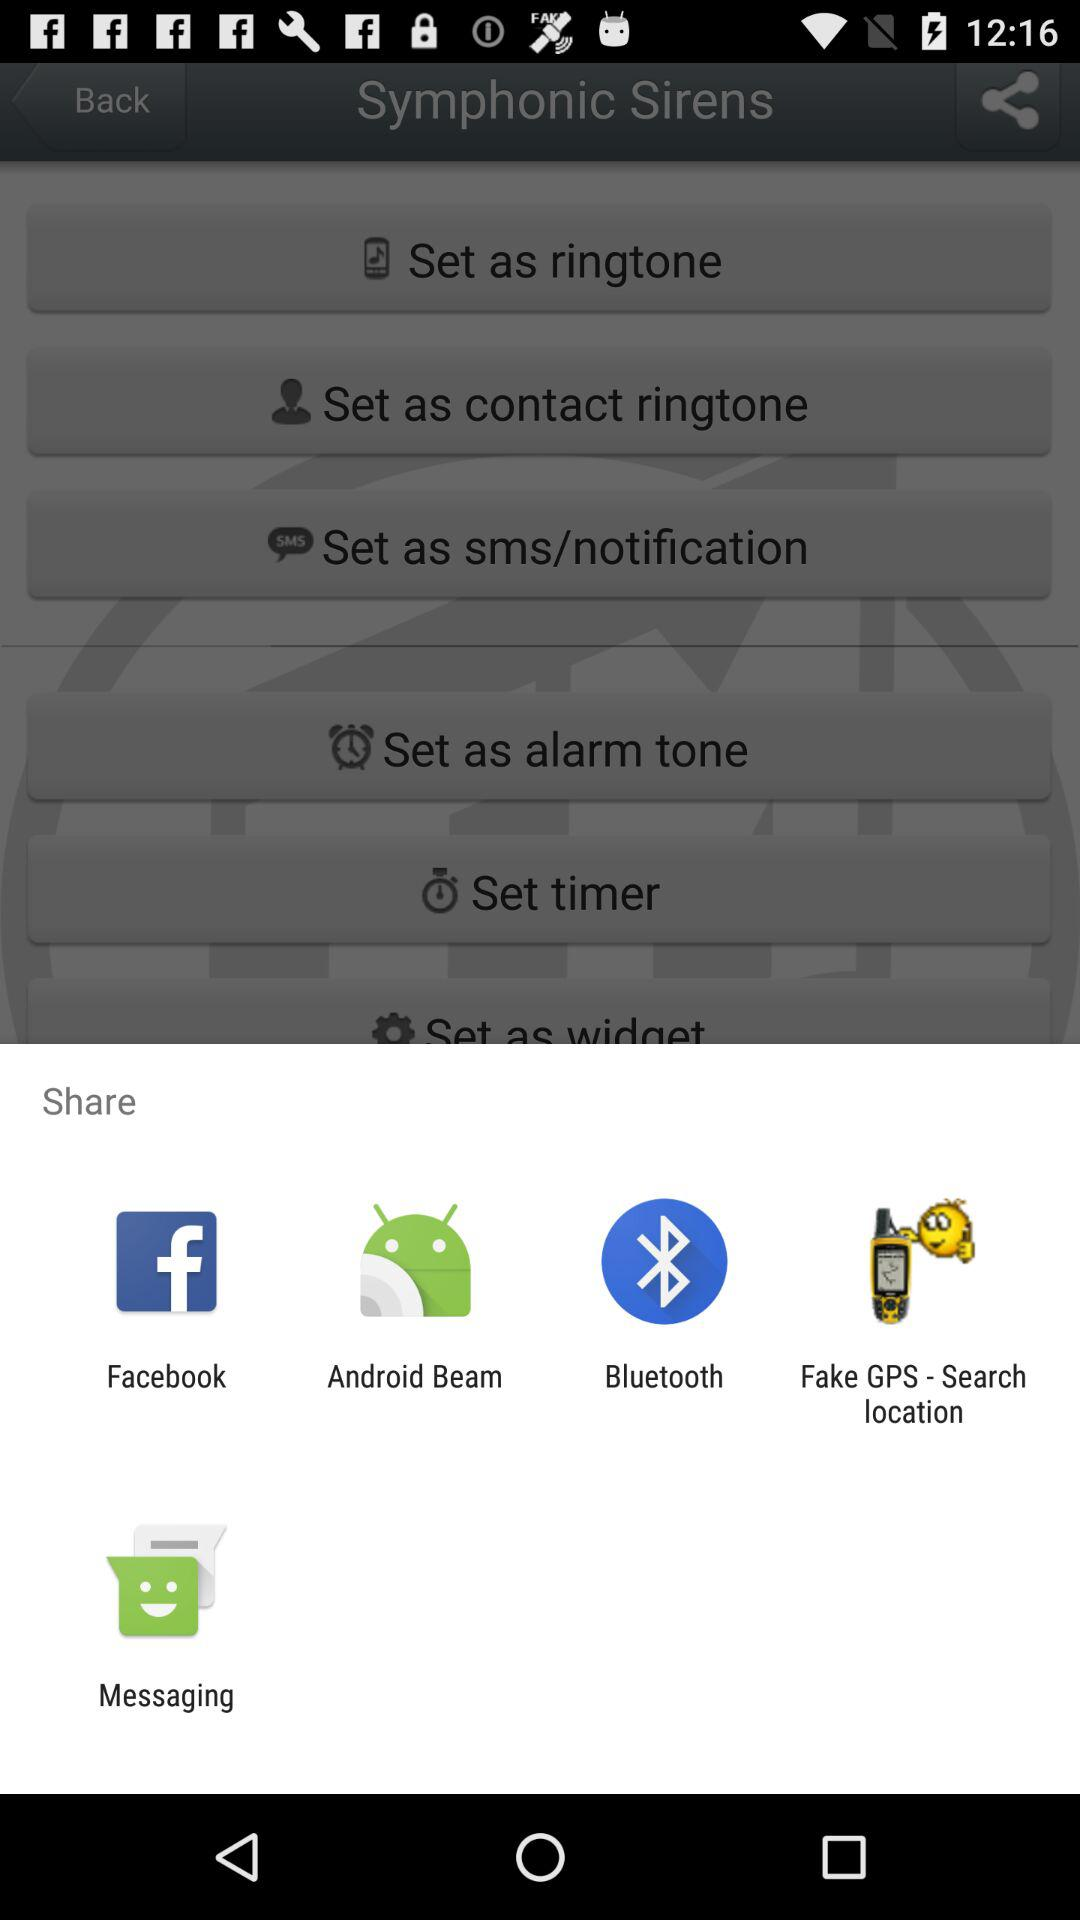How many notifications are there?
When the provided information is insufficient, respond with <no answer>. <no answer> 